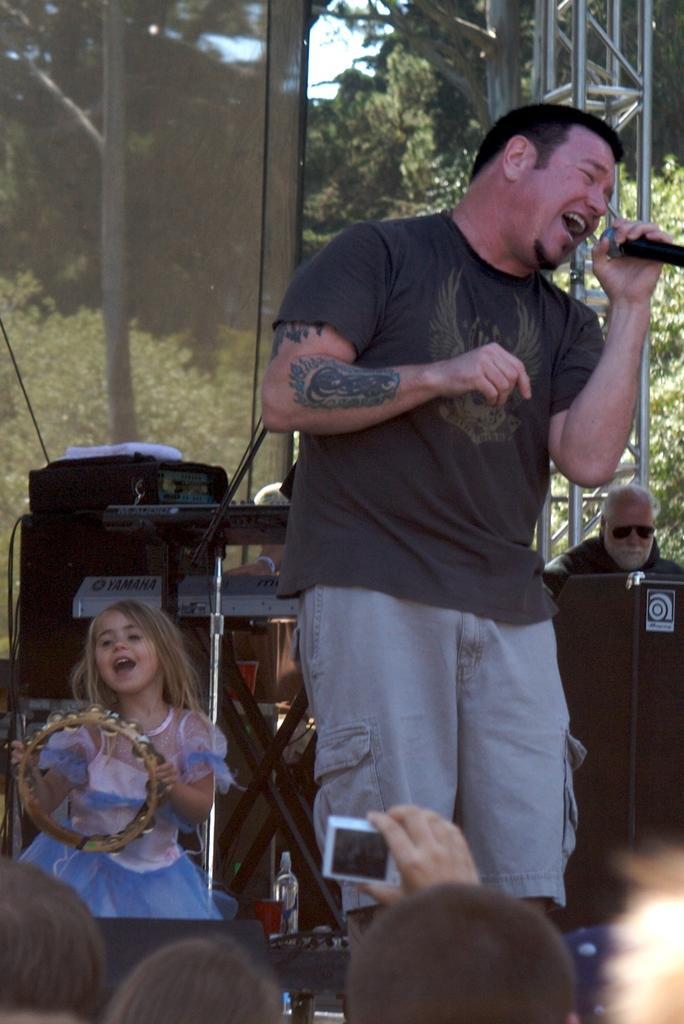Please provide a concise description of this image. A man is singing with a mic in his hand and a girl behind him is playing a musical instrument. 